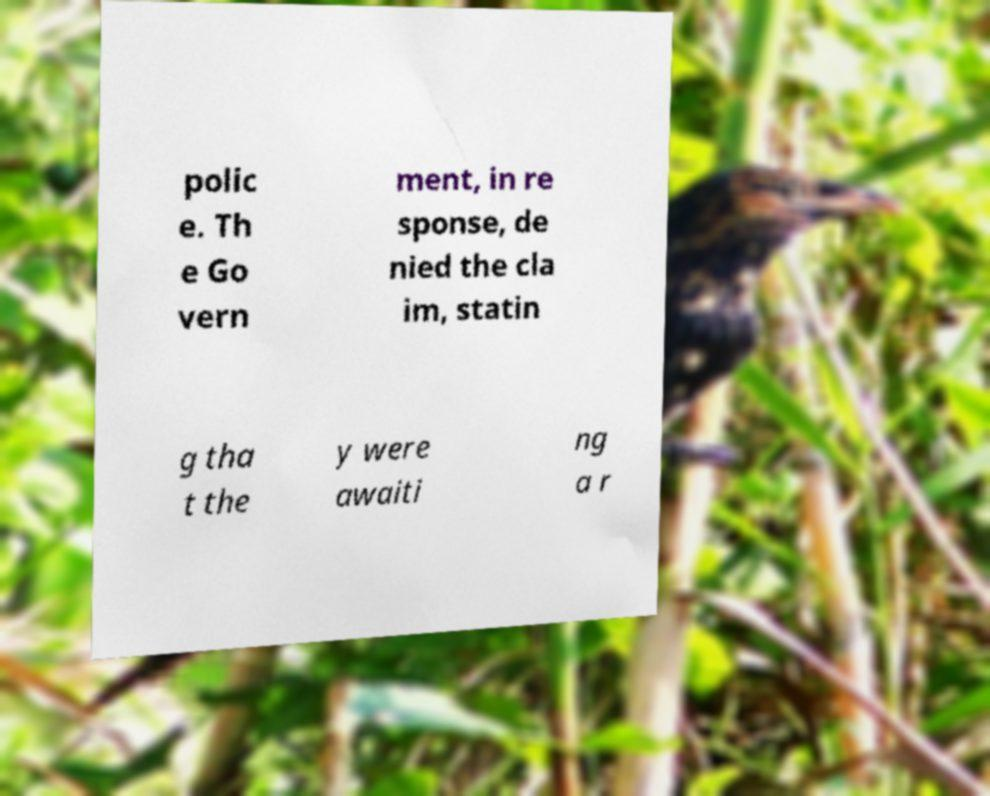For documentation purposes, I need the text within this image transcribed. Could you provide that? polic e. Th e Go vern ment, in re sponse, de nied the cla im, statin g tha t the y were awaiti ng a r 